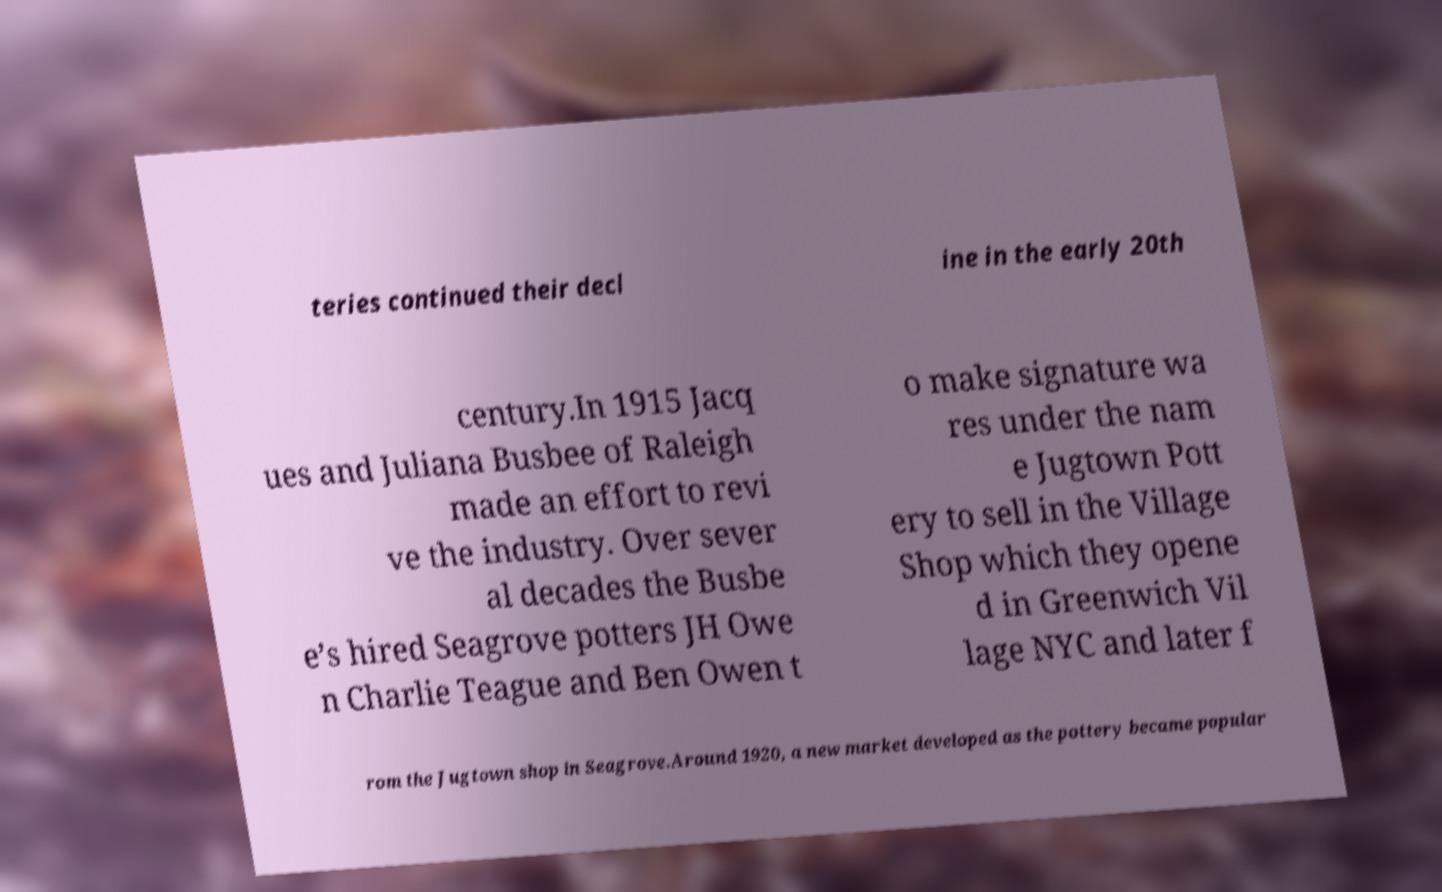Could you assist in decoding the text presented in this image and type it out clearly? teries continued their decl ine in the early 20th century.In 1915 Jacq ues and Juliana Busbee of Raleigh made an effort to revi ve the industry. Over sever al decades the Busbe e’s hired Seagrove potters JH Owe n Charlie Teague and Ben Owen t o make signature wa res under the nam e Jugtown Pott ery to sell in the Village Shop which they opene d in Greenwich Vil lage NYC and later f rom the Jugtown shop in Seagrove.Around 1920, a new market developed as the pottery became popular 